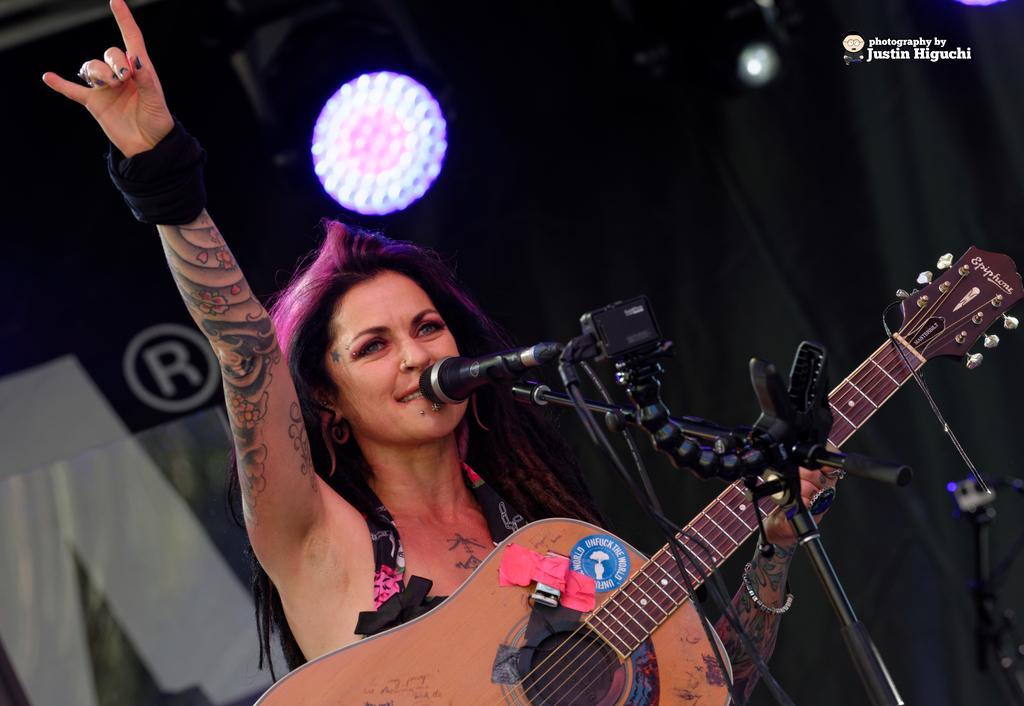Please provide a concise description of this image. This picture shows a woman standing and holding a guitar in her hand and she is speaking with the help of a microphone in front of her 